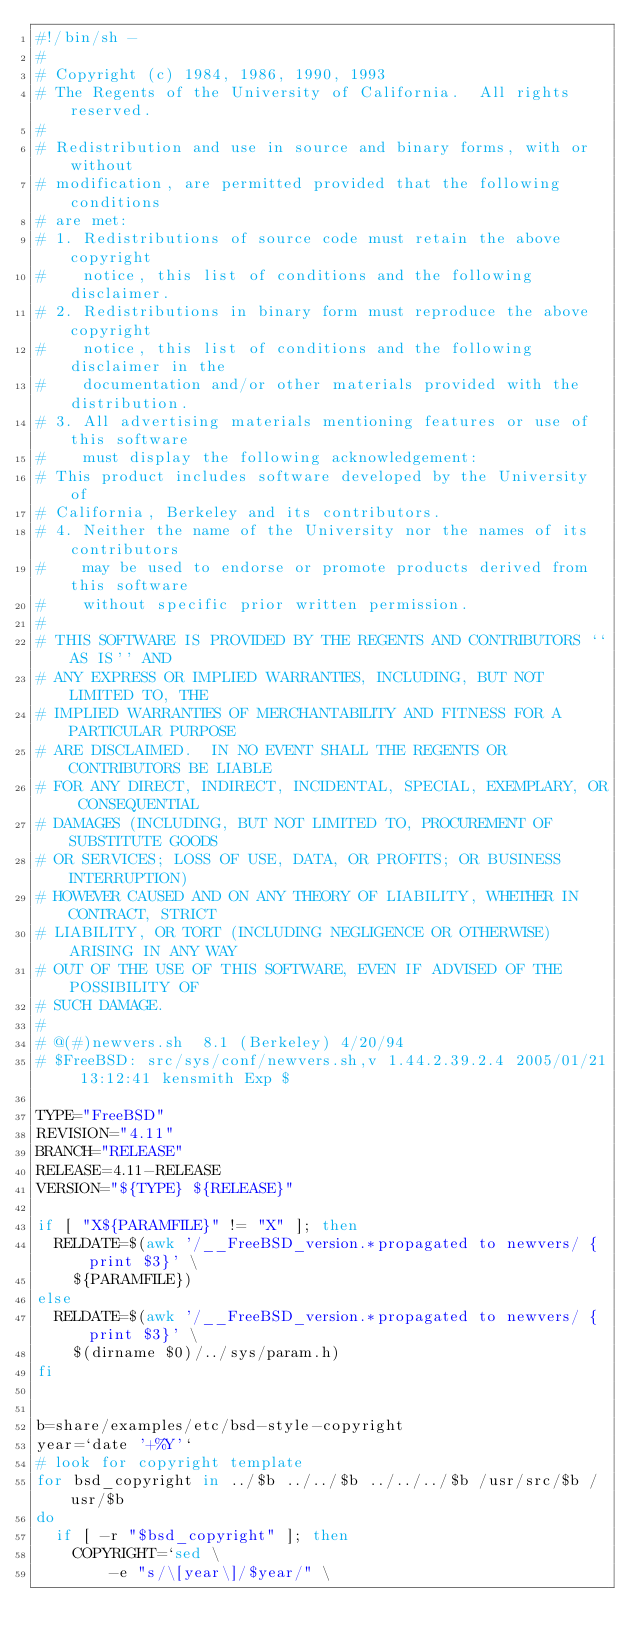Convert code to text. <code><loc_0><loc_0><loc_500><loc_500><_Bash_>#!/bin/sh -
#
# Copyright (c) 1984, 1986, 1990, 1993
#	The Regents of the University of California.  All rights reserved.
#
# Redistribution and use in source and binary forms, with or without
# modification, are permitted provided that the following conditions
# are met:
# 1. Redistributions of source code must retain the above copyright
#    notice, this list of conditions and the following disclaimer.
# 2. Redistributions in binary form must reproduce the above copyright
#    notice, this list of conditions and the following disclaimer in the
#    documentation and/or other materials provided with the distribution.
# 3. All advertising materials mentioning features or use of this software
#    must display the following acknowledgement:
#	This product includes software developed by the University of
#	California, Berkeley and its contributors.
# 4. Neither the name of the University nor the names of its contributors
#    may be used to endorse or promote products derived from this software
#    without specific prior written permission.
#
# THIS SOFTWARE IS PROVIDED BY THE REGENTS AND CONTRIBUTORS ``AS IS'' AND
# ANY EXPRESS OR IMPLIED WARRANTIES, INCLUDING, BUT NOT LIMITED TO, THE
# IMPLIED WARRANTIES OF MERCHANTABILITY AND FITNESS FOR A PARTICULAR PURPOSE
# ARE DISCLAIMED.  IN NO EVENT SHALL THE REGENTS OR CONTRIBUTORS BE LIABLE
# FOR ANY DIRECT, INDIRECT, INCIDENTAL, SPECIAL, EXEMPLARY, OR CONSEQUENTIAL
# DAMAGES (INCLUDING, BUT NOT LIMITED TO, PROCUREMENT OF SUBSTITUTE GOODS
# OR SERVICES; LOSS OF USE, DATA, OR PROFITS; OR BUSINESS INTERRUPTION)
# HOWEVER CAUSED AND ON ANY THEORY OF LIABILITY, WHETHER IN CONTRACT, STRICT
# LIABILITY, OR TORT (INCLUDING NEGLIGENCE OR OTHERWISE) ARISING IN ANY WAY
# OUT OF THE USE OF THIS SOFTWARE, EVEN IF ADVISED OF THE POSSIBILITY OF
# SUCH DAMAGE.
#
#	@(#)newvers.sh	8.1 (Berkeley) 4/20/94
# $FreeBSD: src/sys/conf/newvers.sh,v 1.44.2.39.2.4 2005/01/21 13:12:41 kensmith Exp $

TYPE="FreeBSD"
REVISION="4.11"
BRANCH="RELEASE"
RELEASE=4.11-RELEASE
VERSION="${TYPE} ${RELEASE}"

if [ "X${PARAMFILE}" != "X" ]; then
	RELDATE=$(awk '/__FreeBSD_version.*propagated to newvers/ {print $3}' \
		${PARAMFILE})
else
	RELDATE=$(awk '/__FreeBSD_version.*propagated to newvers/ {print $3}' \
		$(dirname $0)/../sys/param.h)
fi


b=share/examples/etc/bsd-style-copyright
year=`date '+%Y'`
# look for copyright template
for bsd_copyright in ../$b ../../$b ../../../$b /usr/src/$b /usr/$b
do
	if [ -r "$bsd_copyright" ]; then
		COPYRIGHT=`sed \
		    -e "s/\[year\]/$year/" \</code> 